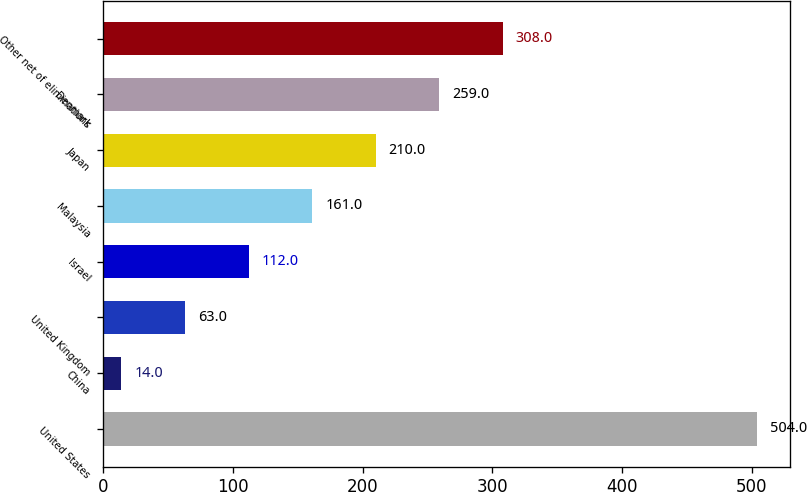Convert chart to OTSL. <chart><loc_0><loc_0><loc_500><loc_500><bar_chart><fcel>United States<fcel>China<fcel>United Kingdom<fcel>Israel<fcel>Malaysia<fcel>Japan<fcel>Denmark<fcel>Other net of eliminations<nl><fcel>504<fcel>14<fcel>63<fcel>112<fcel>161<fcel>210<fcel>259<fcel>308<nl></chart> 